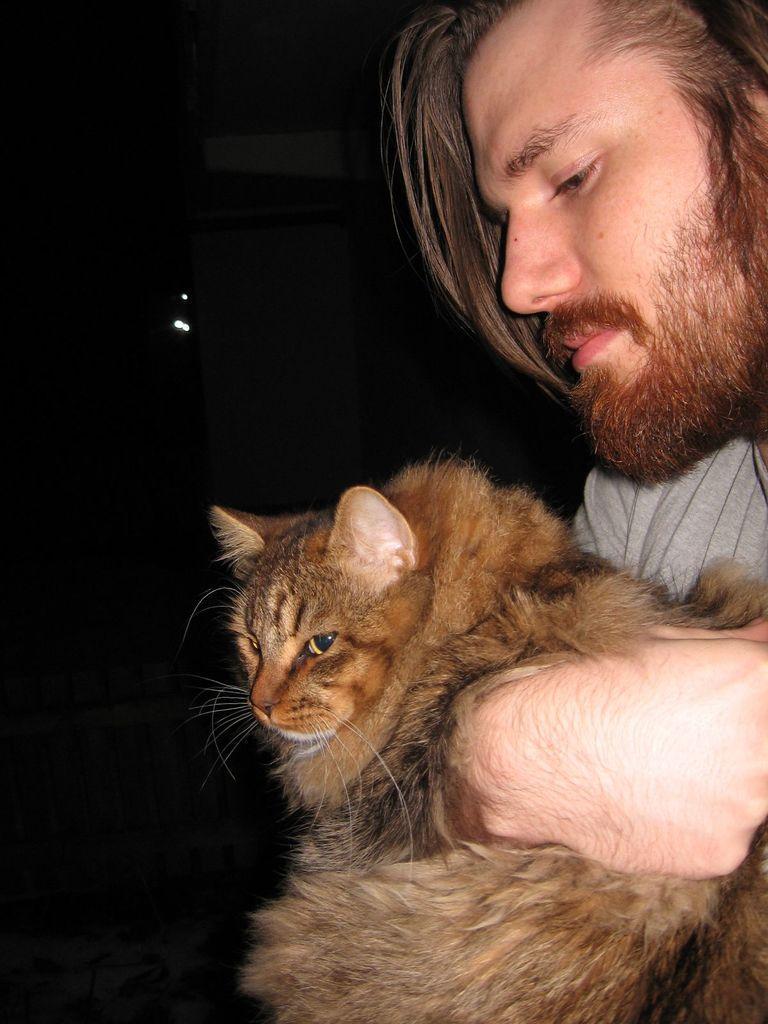In one or two sentences, can you explain what this image depicts? in this image i can see a cat which is holded by a person. he has beard and silky hair. 